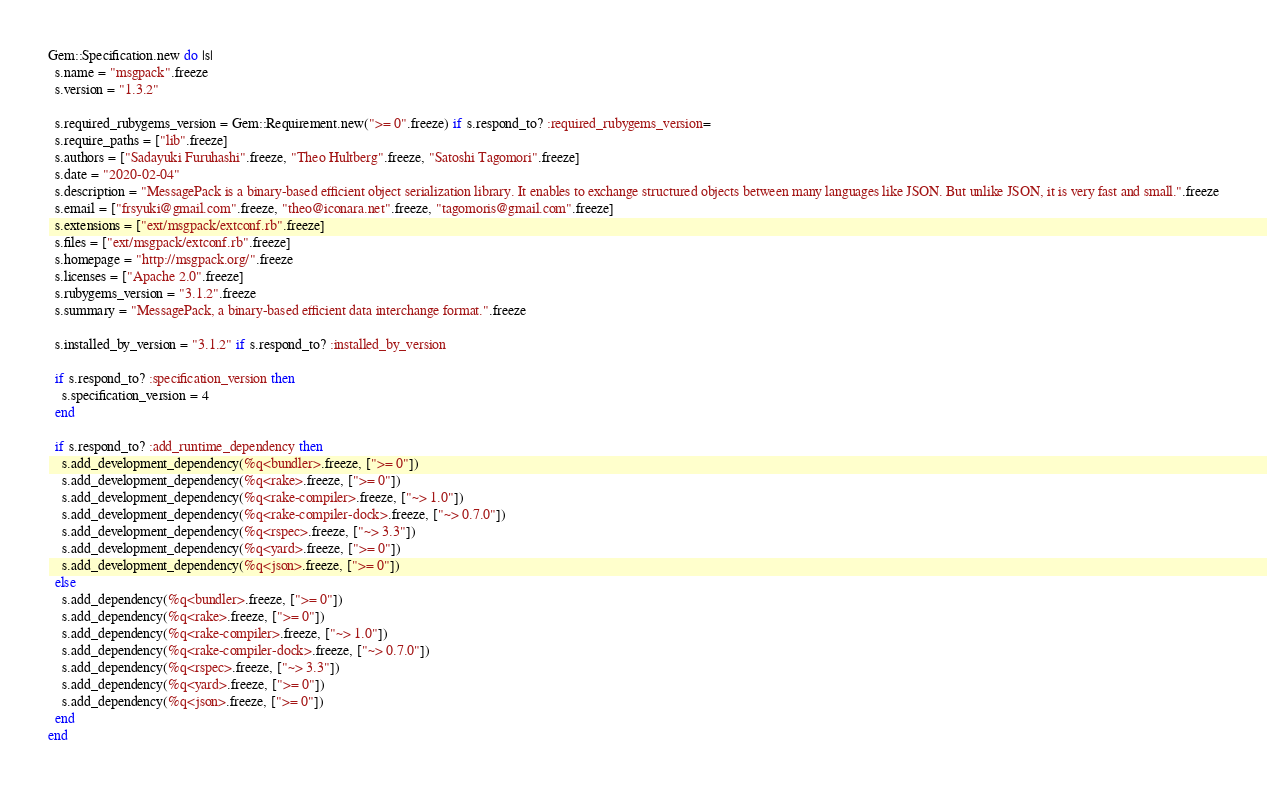Convert code to text. <code><loc_0><loc_0><loc_500><loc_500><_Ruby_>Gem::Specification.new do |s|
  s.name = "msgpack".freeze
  s.version = "1.3.2"

  s.required_rubygems_version = Gem::Requirement.new(">= 0".freeze) if s.respond_to? :required_rubygems_version=
  s.require_paths = ["lib".freeze]
  s.authors = ["Sadayuki Furuhashi".freeze, "Theo Hultberg".freeze, "Satoshi Tagomori".freeze]
  s.date = "2020-02-04"
  s.description = "MessagePack is a binary-based efficient object serialization library. It enables to exchange structured objects between many languages like JSON. But unlike JSON, it is very fast and small.".freeze
  s.email = ["frsyuki@gmail.com".freeze, "theo@iconara.net".freeze, "tagomoris@gmail.com".freeze]
  s.extensions = ["ext/msgpack/extconf.rb".freeze]
  s.files = ["ext/msgpack/extconf.rb".freeze]
  s.homepage = "http://msgpack.org/".freeze
  s.licenses = ["Apache 2.0".freeze]
  s.rubygems_version = "3.1.2".freeze
  s.summary = "MessagePack, a binary-based efficient data interchange format.".freeze

  s.installed_by_version = "3.1.2" if s.respond_to? :installed_by_version

  if s.respond_to? :specification_version then
    s.specification_version = 4
  end

  if s.respond_to? :add_runtime_dependency then
    s.add_development_dependency(%q<bundler>.freeze, [">= 0"])
    s.add_development_dependency(%q<rake>.freeze, [">= 0"])
    s.add_development_dependency(%q<rake-compiler>.freeze, ["~> 1.0"])
    s.add_development_dependency(%q<rake-compiler-dock>.freeze, ["~> 0.7.0"])
    s.add_development_dependency(%q<rspec>.freeze, ["~> 3.3"])
    s.add_development_dependency(%q<yard>.freeze, [">= 0"])
    s.add_development_dependency(%q<json>.freeze, [">= 0"])
  else
    s.add_dependency(%q<bundler>.freeze, [">= 0"])
    s.add_dependency(%q<rake>.freeze, [">= 0"])
    s.add_dependency(%q<rake-compiler>.freeze, ["~> 1.0"])
    s.add_dependency(%q<rake-compiler-dock>.freeze, ["~> 0.7.0"])
    s.add_dependency(%q<rspec>.freeze, ["~> 3.3"])
    s.add_dependency(%q<yard>.freeze, [">= 0"])
    s.add_dependency(%q<json>.freeze, [">= 0"])
  end
end
</code> 